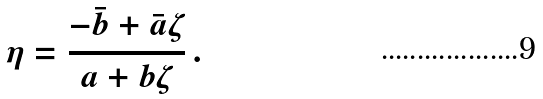Convert formula to latex. <formula><loc_0><loc_0><loc_500><loc_500>\eta = \frac { - \bar { b } + \bar { a } \zeta } { a + b \zeta } \, .</formula> 